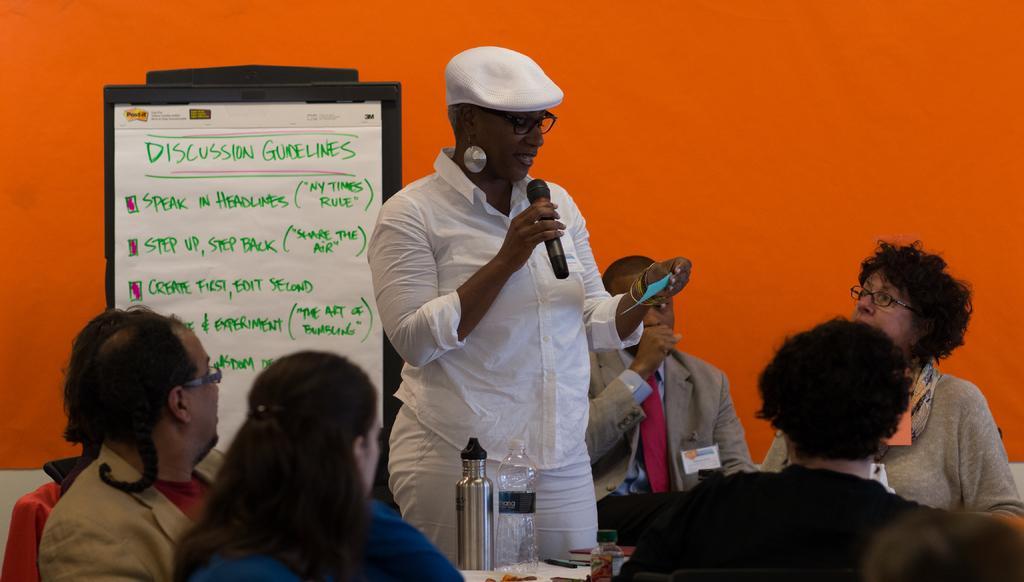Can you describe this image briefly? It is a conference there are group of people sitting in an order and in between them a person is standing and she is reading something she is wearing white dress and behind her on the board there are some guidelines written and in the background there is an orange wall. 